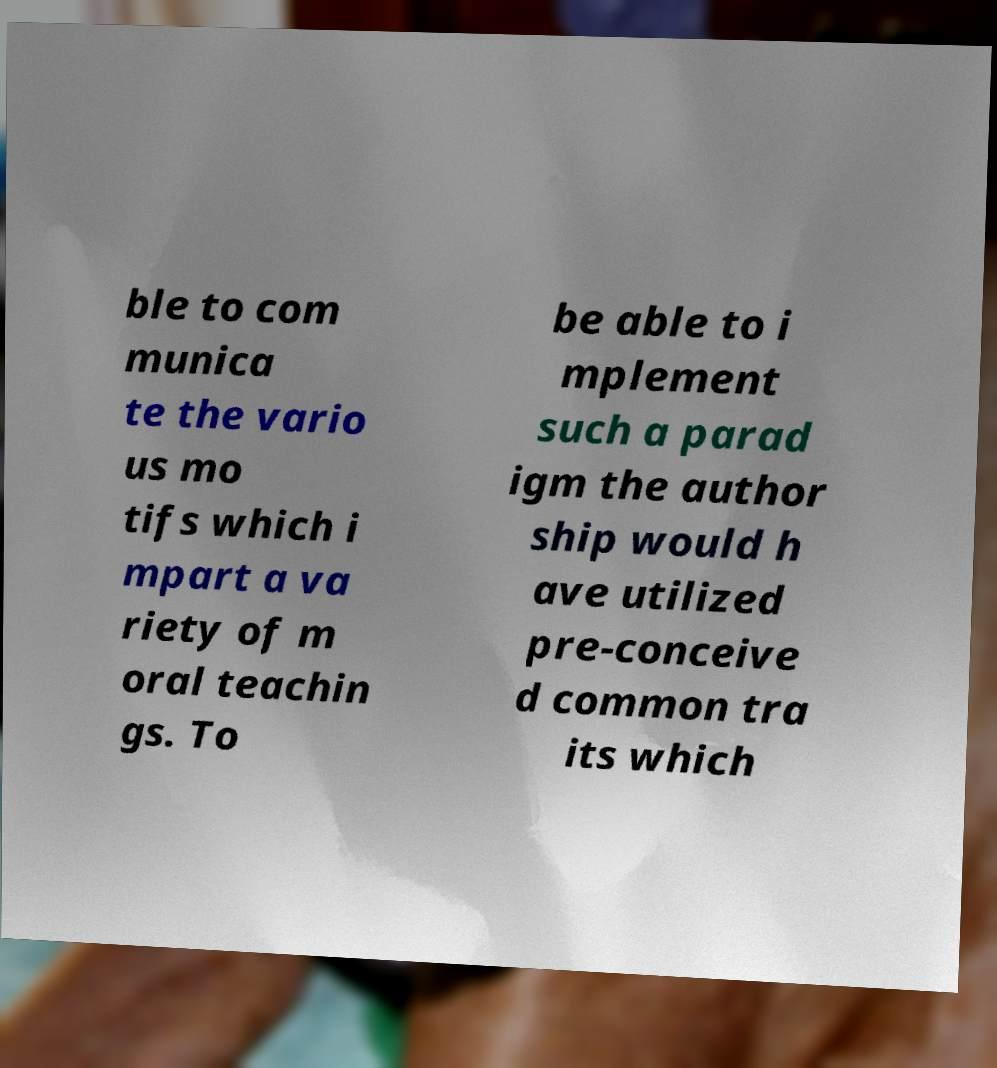What messages or text are displayed in this image? I need them in a readable, typed format. ble to com munica te the vario us mo tifs which i mpart a va riety of m oral teachin gs. To be able to i mplement such a parad igm the author ship would h ave utilized pre-conceive d common tra its which 